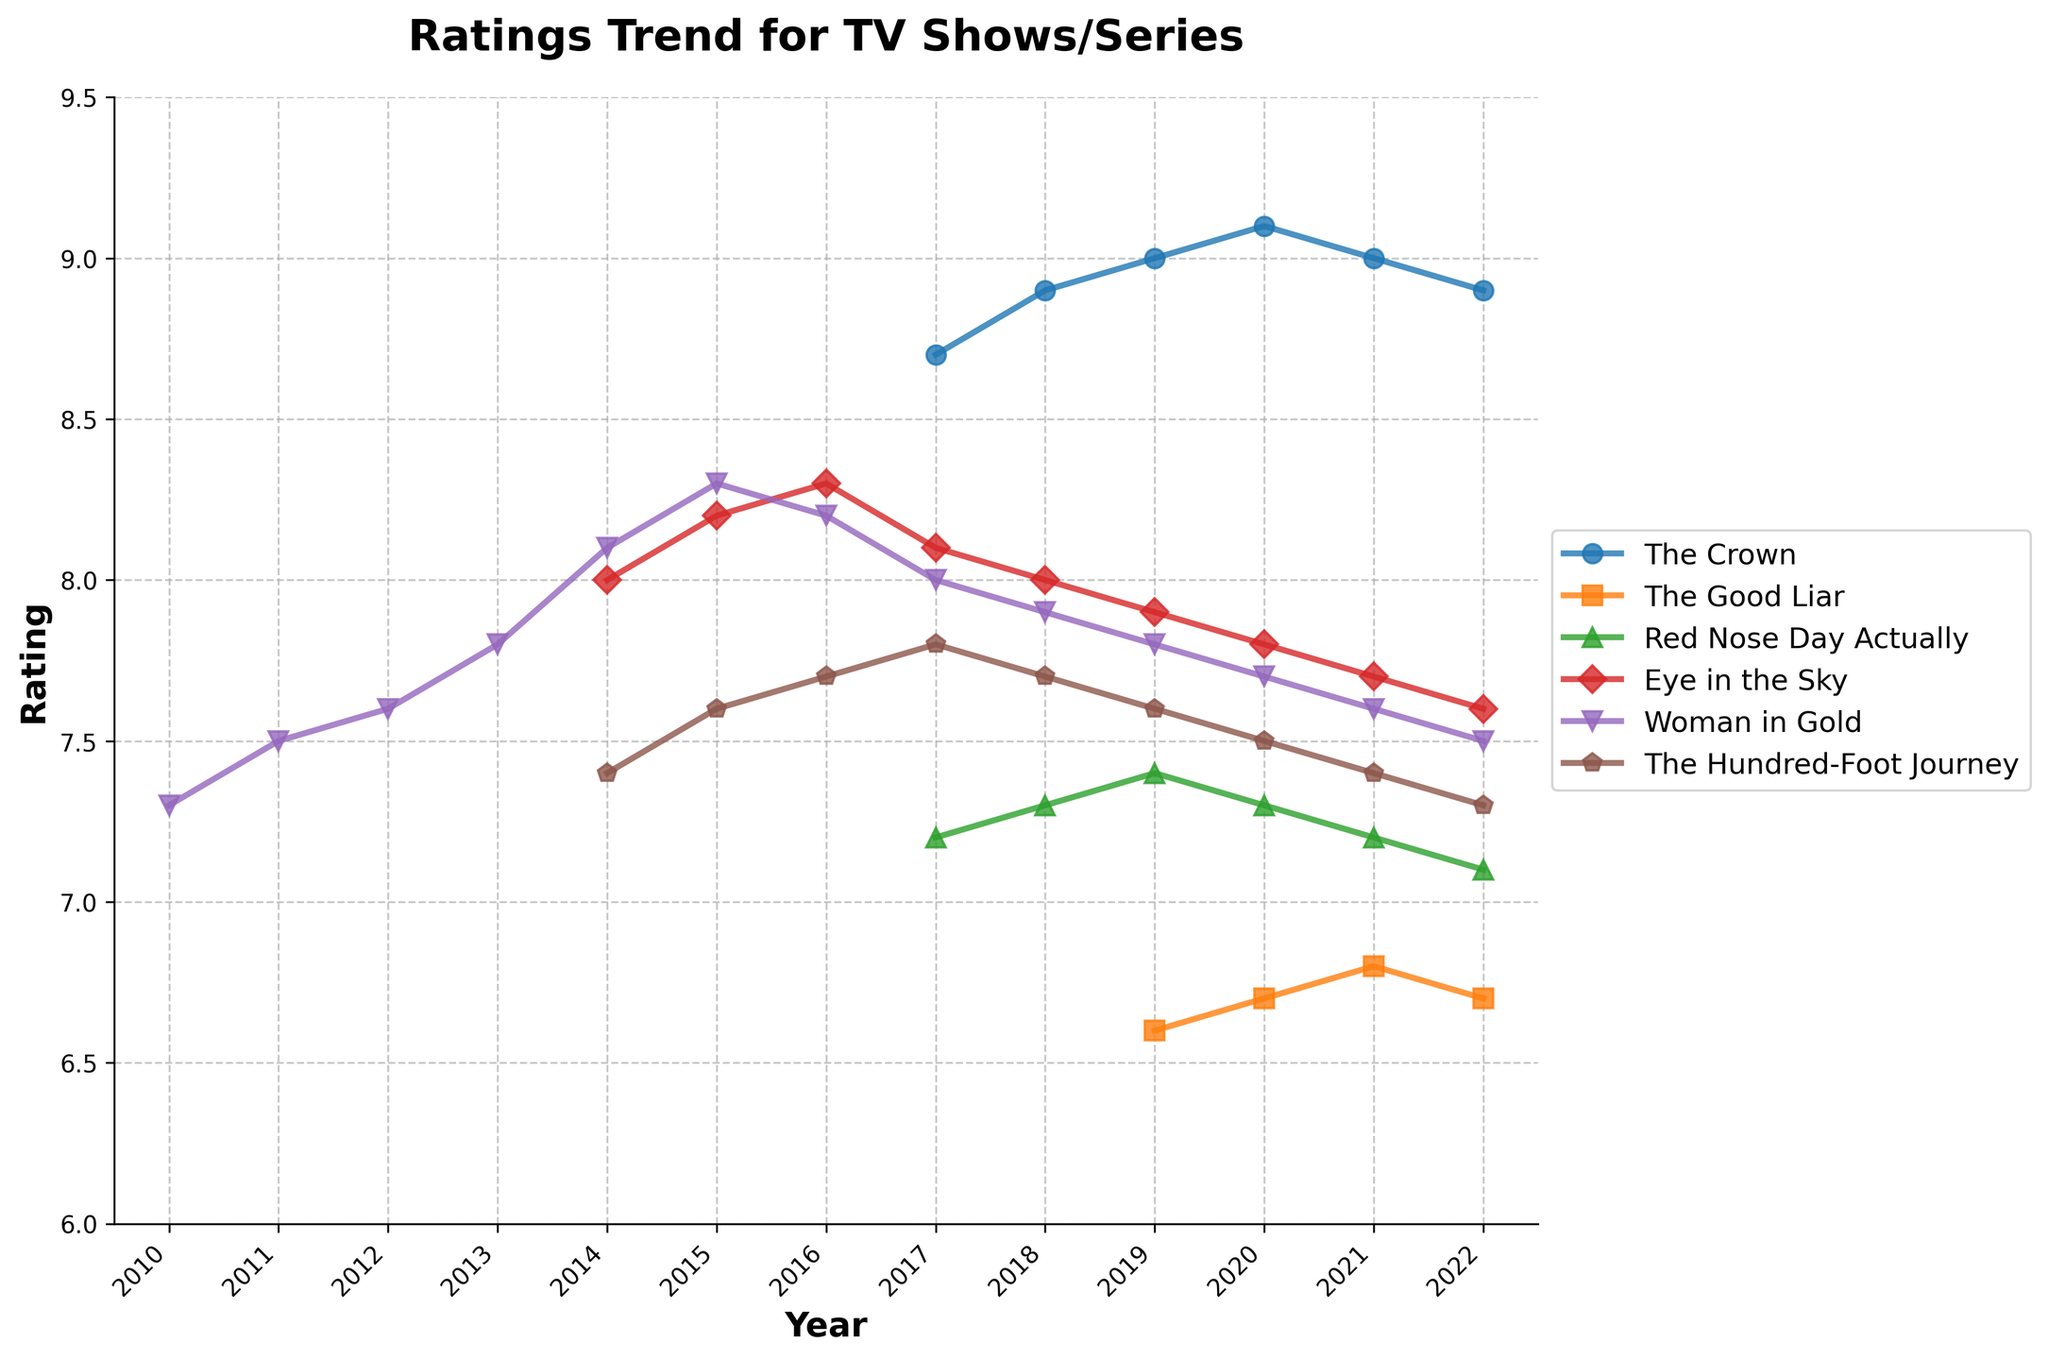What is the general trend in the rating for "The Crown" from 2017 to 2022? Observe the "The Crown" line from 2017 to 2022. The line starts at 8.7 in 2017, rises to 9.1 in 2020, and then slightly falls to 8.9 by 2022.
Answer: Increasing until 2020, then slightly decreasing Which TV show had the highest rating in 2020? Look at the ratings for all the TV shows in 2020 and identify the highest one. "The Crown" has the highest rating in 2020 with a rating of 9.1.
Answer: The Crown How did the rating for "Red Nose Day Actually" change from 2017 to 2022? Observe the "Red Nose Day Actually" line from 2017 to 2022. The rating starts at 7.2 in 2017 and decreases slightly each year, reaching 7.1 in 2022.
Answer: Decreased slightly Which series had the most stable ratings trend from 2014 to 2022? Compare all the series' lines for the smoothest trend from 2014 to 2022. "The Hundred-Foot Journey" line appears the most stable with only minor fluctuations.
Answer: The Hundred-Foot Journey In which year did "Woman in Gold" and "The Hundred-Foot Journey" have the same rating? Observe both lines for intersection points. Both series had the same rating of 7.6 in 2022.
Answer: 2022 What is the average rating for "Eye in the Sky" from 2014 to 2022? Add each annual rating of "Eye in the Sky" from 2014 to 2022 and divide by the count (7 ratings). The sum is 7.4 + 7.6 + 7.7 + 7.8 + 7.9 + 8.0 + 8.1 + 8.2 = 62.7; thus, the average is 62.7/8 = 7.84.
Answer: 7.84 Which year shows the lowest rating for "The Good Liar"? Identify the lowest point on "The Good Liar" line. The lowest rating was 6.6 in 2019.
Answer: 2019 Did "The Crown" ever reach a rating of 9 or higher between 2017 and 2022? Observe "The Crown" line for any points at or above 9 between 2017 and 2022. It reached 9.0 in 2019 and 9.1 in 2020.
Answer: Yes How many TV shows had a rating above 8.0 in 2017? Observe the ratings for all TV shows in 2017 and count those above 8. "The Crown" (8.7) and "Woman in Gold" (8.0) are the TV shows with ratings above 8.
Answer: 2 